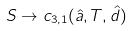<formula> <loc_0><loc_0><loc_500><loc_500>S \rightarrow c _ { 3 , 1 } ( \hat { a } , T , \hat { d } )</formula> 